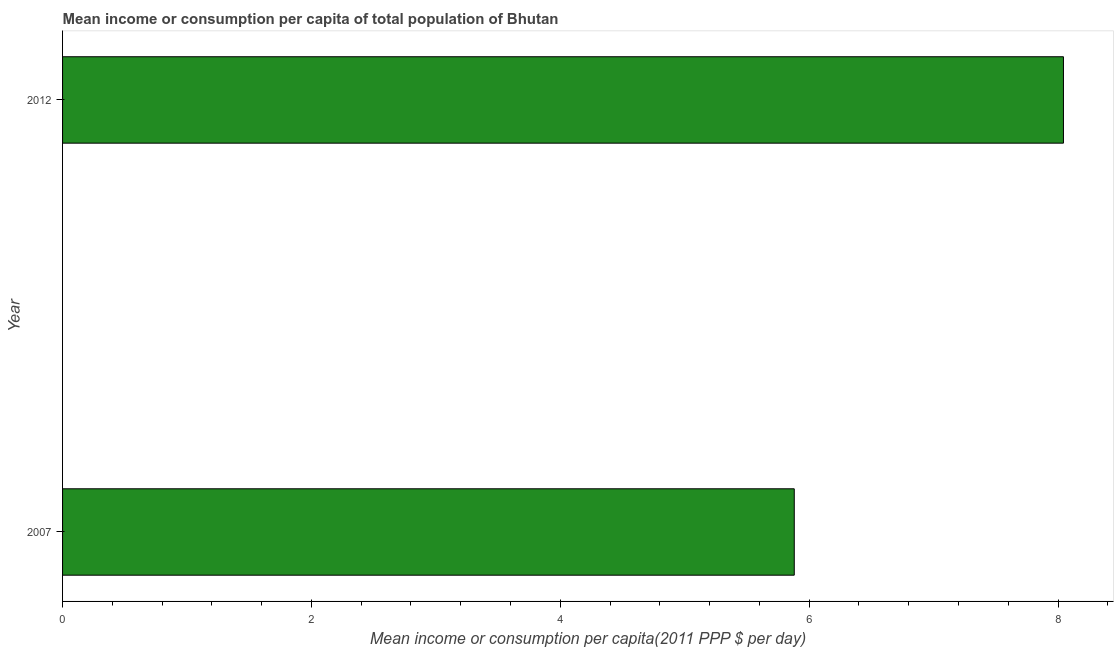What is the title of the graph?
Give a very brief answer. Mean income or consumption per capita of total population of Bhutan. What is the label or title of the X-axis?
Offer a terse response. Mean income or consumption per capita(2011 PPP $ per day). What is the label or title of the Y-axis?
Provide a succinct answer. Year. What is the mean income or consumption in 2007?
Your answer should be very brief. 5.88. Across all years, what is the maximum mean income or consumption?
Offer a very short reply. 8.04. Across all years, what is the minimum mean income or consumption?
Offer a very short reply. 5.88. In which year was the mean income or consumption maximum?
Make the answer very short. 2012. In which year was the mean income or consumption minimum?
Make the answer very short. 2007. What is the sum of the mean income or consumption?
Make the answer very short. 13.92. What is the difference between the mean income or consumption in 2007 and 2012?
Ensure brevity in your answer.  -2.16. What is the average mean income or consumption per year?
Your response must be concise. 6.96. What is the median mean income or consumption?
Make the answer very short. 6.96. Do a majority of the years between 2007 and 2012 (inclusive) have mean income or consumption greater than 3.2 $?
Provide a succinct answer. Yes. What is the ratio of the mean income or consumption in 2007 to that in 2012?
Offer a very short reply. 0.73. Are all the bars in the graph horizontal?
Provide a succinct answer. Yes. What is the difference between two consecutive major ticks on the X-axis?
Your answer should be very brief. 2. Are the values on the major ticks of X-axis written in scientific E-notation?
Your response must be concise. No. What is the Mean income or consumption per capita(2011 PPP $ per day) in 2007?
Offer a terse response. 5.88. What is the Mean income or consumption per capita(2011 PPP $ per day) of 2012?
Give a very brief answer. 8.04. What is the difference between the Mean income or consumption per capita(2011 PPP $ per day) in 2007 and 2012?
Your answer should be very brief. -2.16. What is the ratio of the Mean income or consumption per capita(2011 PPP $ per day) in 2007 to that in 2012?
Provide a short and direct response. 0.73. 